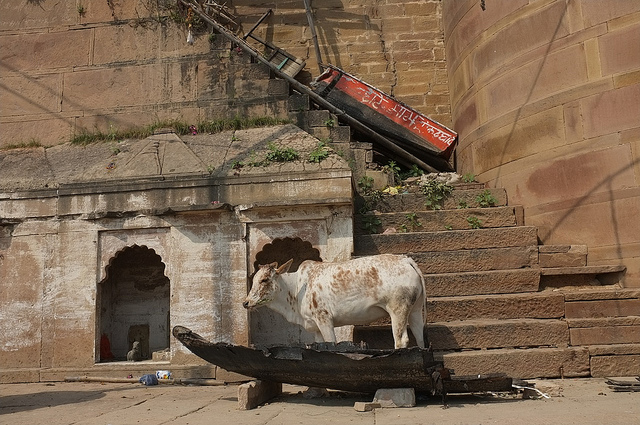Is this a normal place for a cow to be? No, it is quite unusual to see a cow on a boat. Typically, cows are found in fields or barns, not on watercraft. 